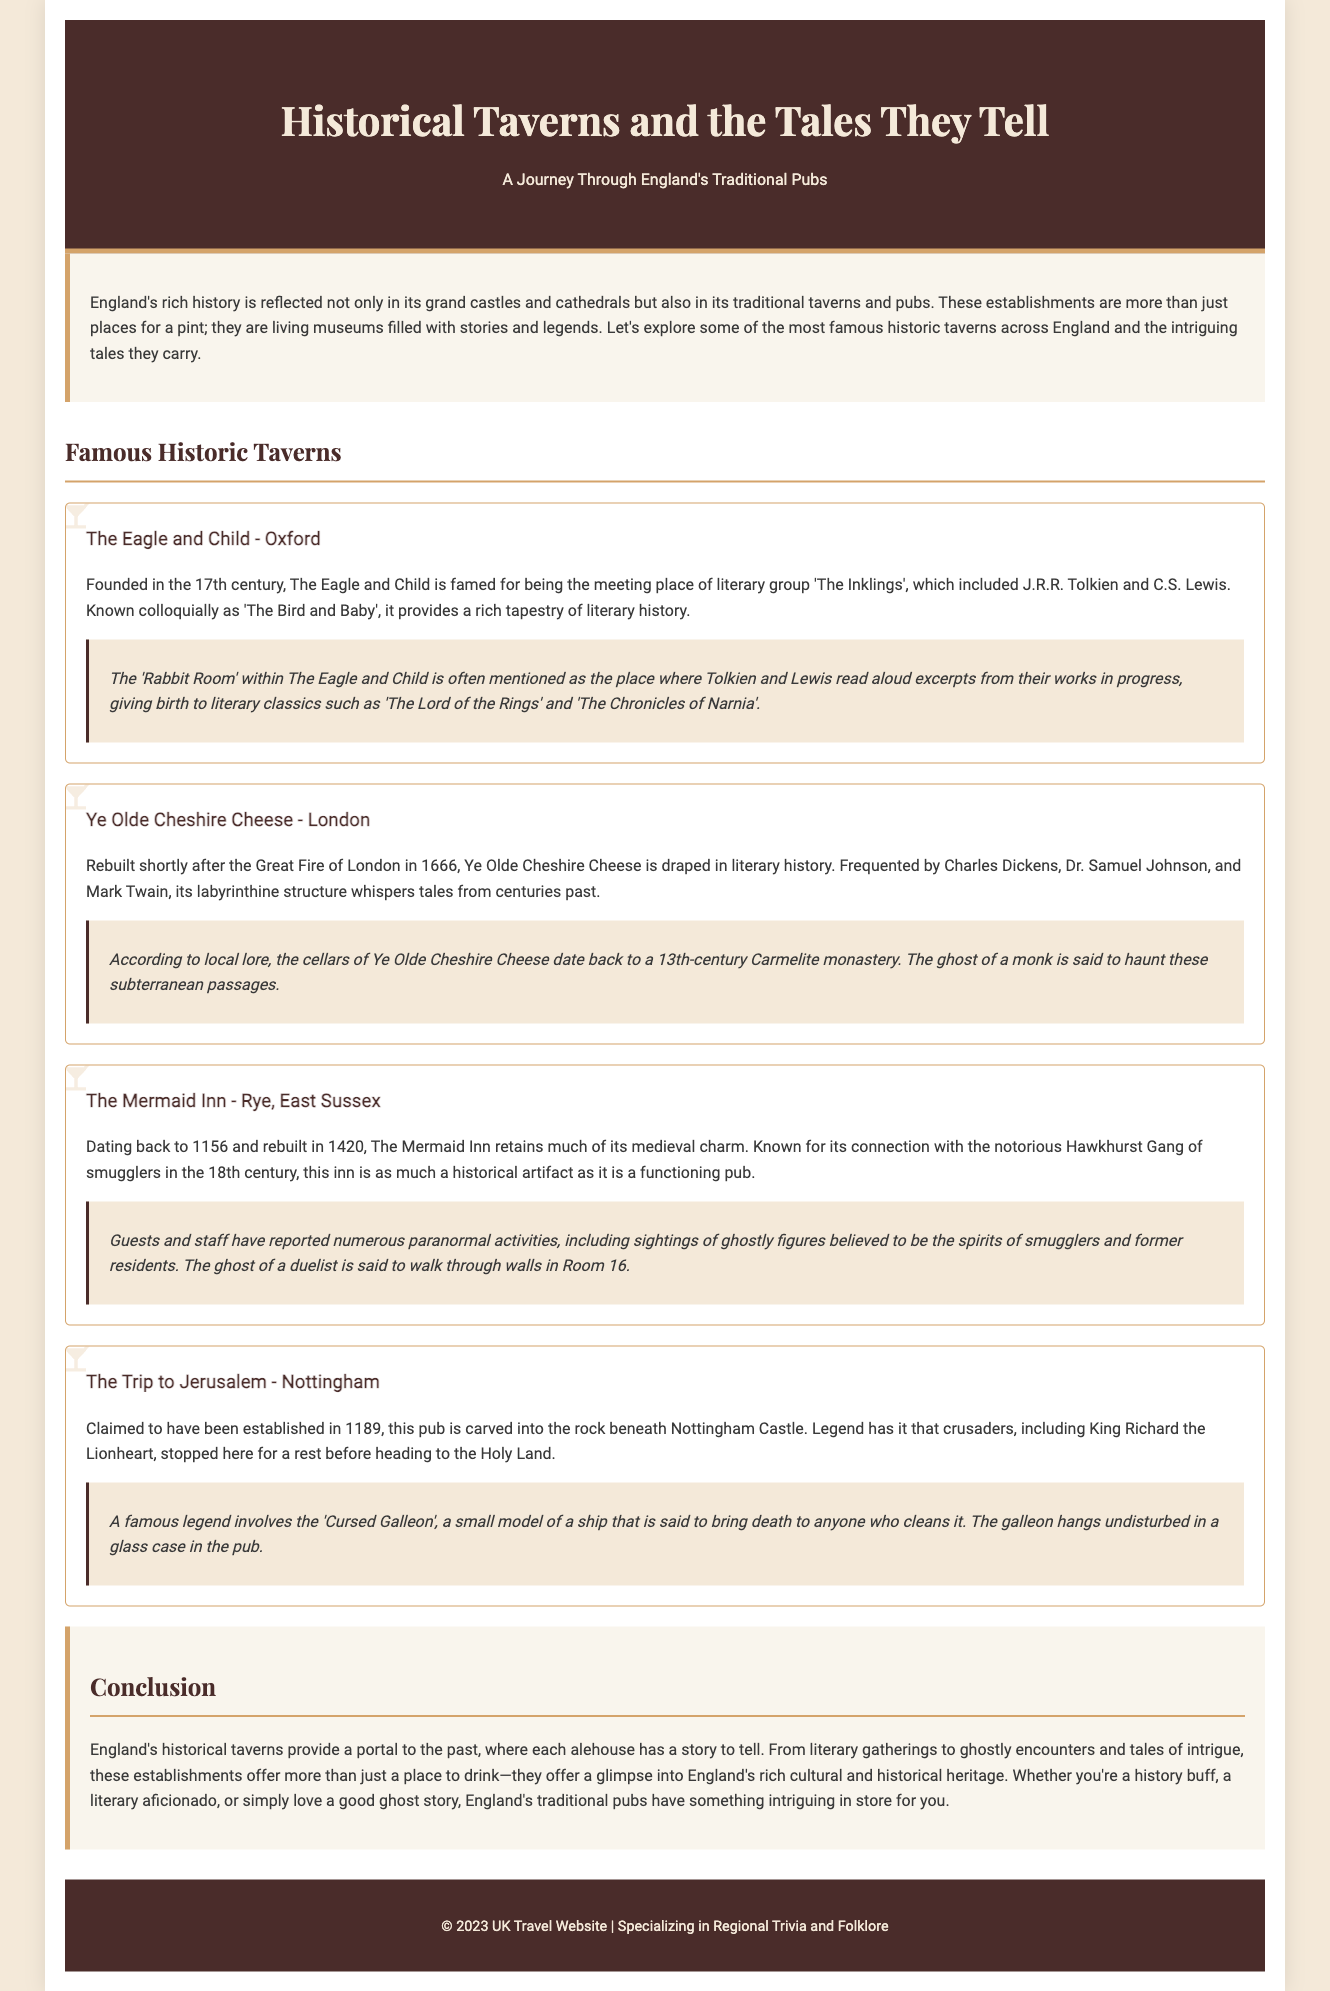What is the name of the literary group that met at The Eagle and Child? The Eagle and Child was the meeting place for the literary group called 'The Inklings', which included famous authors.
Answer: The Inklings In what year was Ye Olde Cheshire Cheese rebuilt? Ye Olde Cheshire Cheese was rebuilt shortly after the Great Fire of London, which occurred in 1666.
Answer: 1666 What notable connection does The Mermaid Inn have with a group of smugglers? The Mermaid Inn is known for its connection with the notorious Hawkhurst Gang of smugglers in the 18th century.
Answer: Hawkhurst Gang Which king is associated with the pub, The Trip to Jerusalem? The Trip to Jerusalem is associated with King Richard the Lionheart, who stopped here before heading to the Holy Land.
Answer: Richard the Lionheart What type of activities have been reported at The Mermaid Inn? Guests and staff at The Mermaid Inn have reported numerous paranormal activities, including ghost sightings.
Answer: Paranormal activities Which legendary item in The Trip to Jerusalem is said to bring death to anyone who cleans it? The item that is said to bring death to anyone who cleans it is the 'Cursed Galleon', a small model ship in the pub.
Answer: Cursed Galleon What is the historical significance of The Eagle and Child's 'Rabbit Room'? The 'Rabbit Room' is significant for being the place where Tolkien and Lewis read excerpts from their works, contributing to their literary classics.
Answer: Birth of literary classics What overarching theme do England's historical taverns represent? England's historical taverns represent the rich cultural and historical heritage of England, serving as portals to the past.
Answer: Cultural and historical heritage 